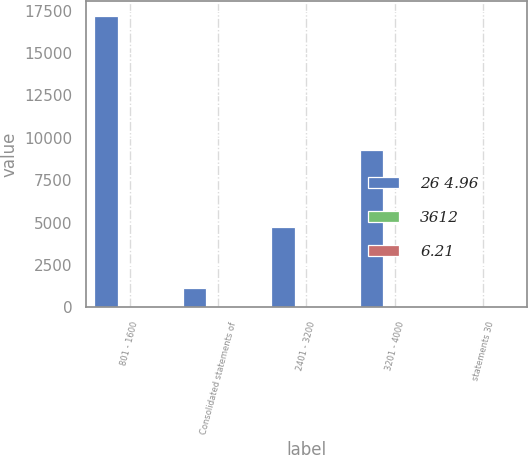Convert chart. <chart><loc_0><loc_0><loc_500><loc_500><stacked_bar_chart><ecel><fcel>801 - 1600<fcel>Consolidated statements of<fcel>2401 - 3200<fcel>3201 - 4000<fcel>statements 30<nl><fcel>26 4.96<fcel>17179<fcel>1146<fcel>4725<fcel>9284<fcel>20.06<nl><fcel>3612<fcel>4.1<fcel>8.43<fcel>9.38<fcel>8.37<fcel>5.85<nl><fcel>6.21<fcel>11.92<fcel>41.95<fcel>27.21<fcel>34.59<fcel>20.06<nl></chart> 